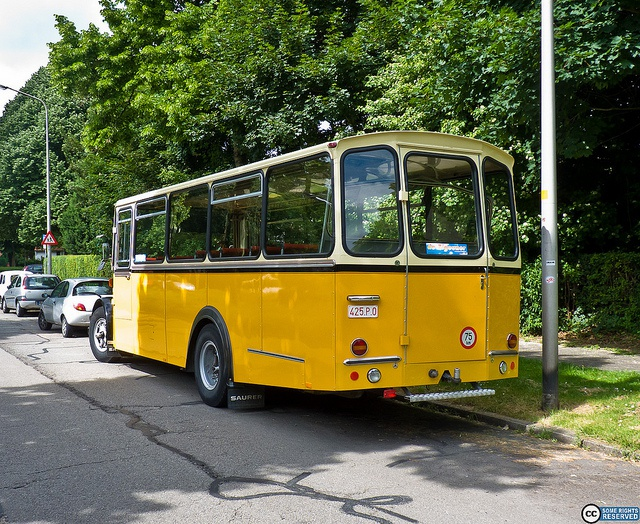Describe the objects in this image and their specific colors. I can see bus in whitesmoke, black, orange, olive, and gray tones, car in white, black, gray, and darkgray tones, car in white, darkgray, black, lightgray, and gray tones, and car in white, darkgray, gray, and black tones in this image. 